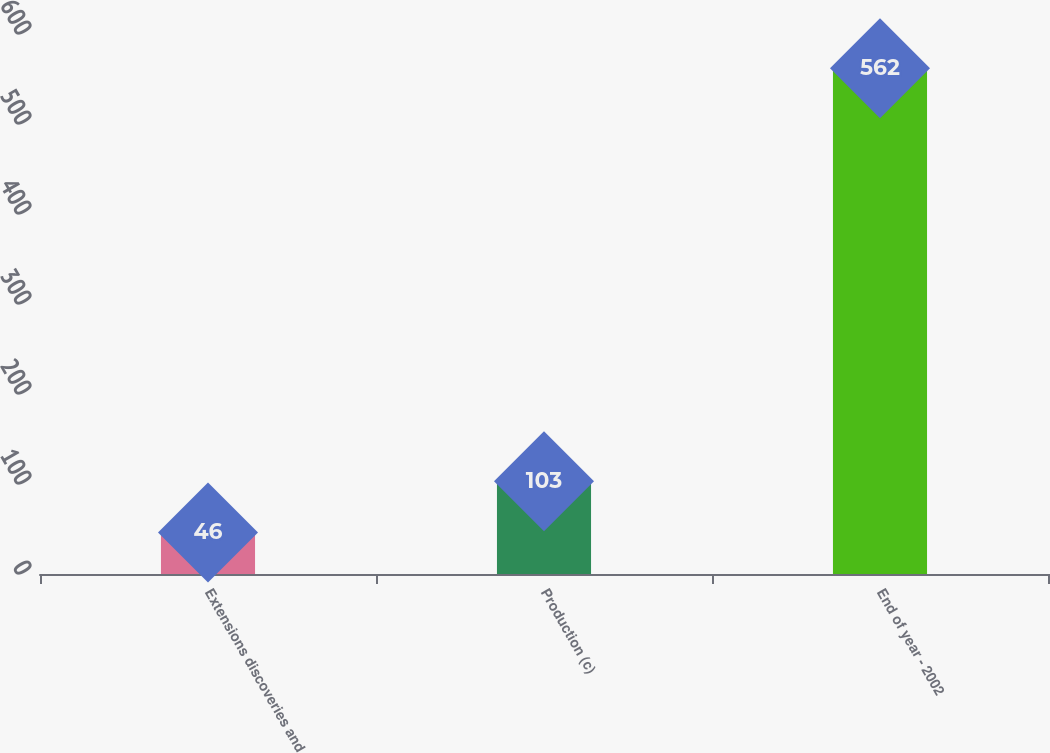Convert chart to OTSL. <chart><loc_0><loc_0><loc_500><loc_500><bar_chart><fcel>Extensions discoveries and<fcel>Production (c)<fcel>End of year - 2002<nl><fcel>46<fcel>103<fcel>562<nl></chart> 